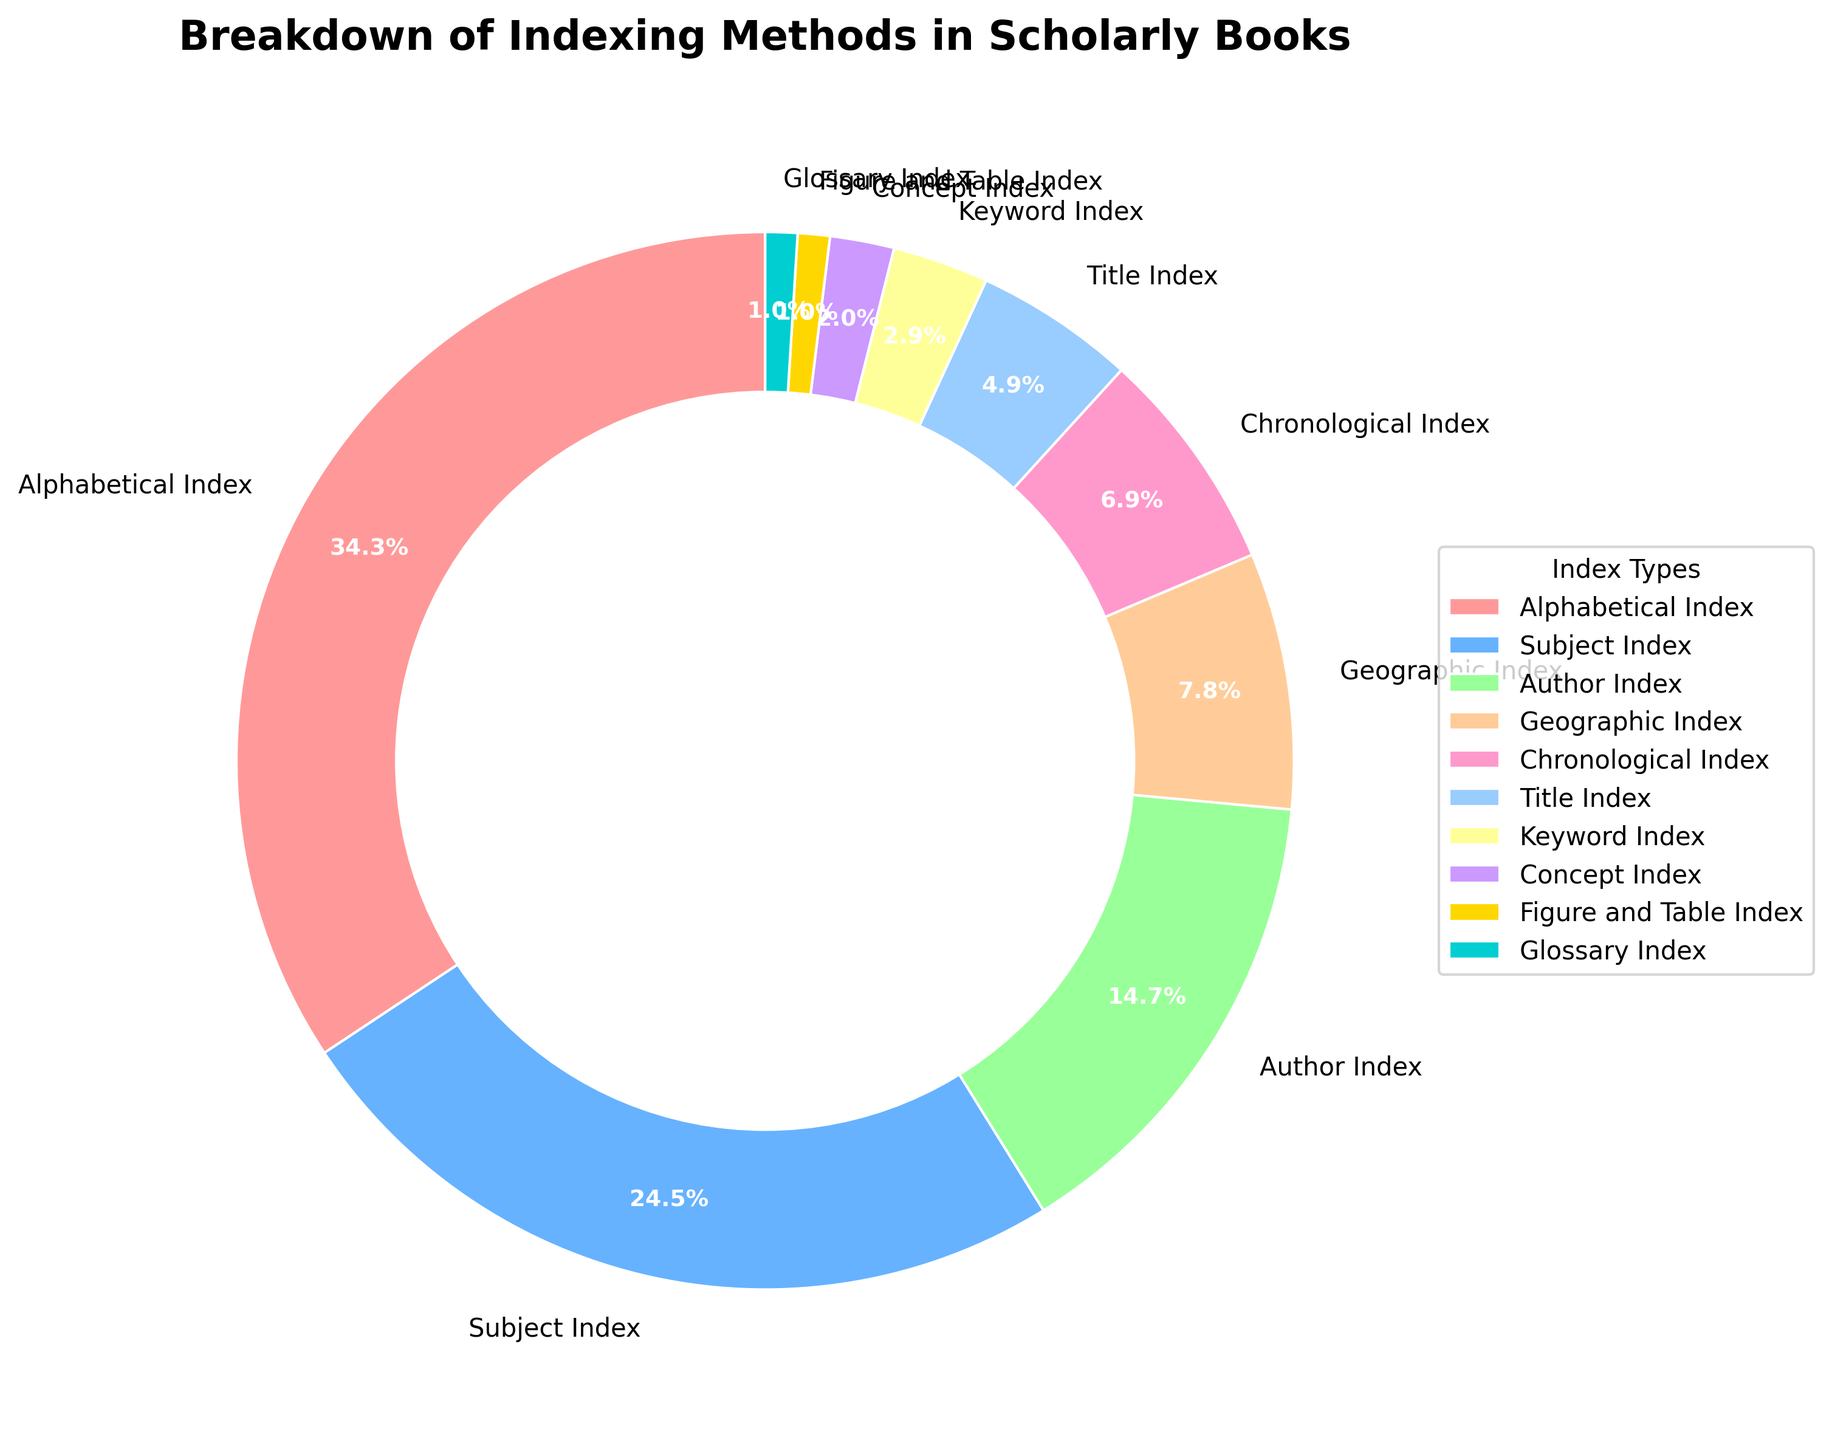Which indexing method is the most commonly used in scholarly books? The pie chart clearly indicates that the "Alphabetical Index" makes up the largest portion, represented by the largest wedge in the chart, at 35%.
Answer: Alphabetical Index What percentage of scholarly books use either a Geographic Index or a Chronological Index? The chart indicates that the Geographic Index is 8% and the Chronological Index is 7%. Adding these two percentages together results in 8% + 7% = 15%.
Answer: 15% Which indexing method has the smallest use in scholarly books? The smallest wedges in the pie chart representing 1% each are the "Figure and Table Index" and the "Glossary Index". They are equally the least used methods.
Answer: Figure and Table Index, Glossary Index How does the usage of the Subject Index compare to the Author Index? According to the pie chart, the Subject Index is used 25% of the time, whereas the Author Index is used 15% of the time. Thus, the Subject Index is used more frequently.
Answer: Subject Index is used more What is the combined percentage of scholarly books that use Keyword Index and Concept Index? The pie chart shows that Keyword Index is 3% and Concept Index is 2%. Combining these two percentages results in 3% + 2% = 5%.
Answer: 5% Is the usage of the Title Index closer to the usage of the Geographic Index or the Chronological Index? The pie chart shows that the Title Index is 5%, the Geographic Index is 8%, and the Chronological Index is 7%. Since 5% is closer to 7% than 8%, the Title Index is closer in usage to the Chronological Index.
Answer: Chronological Index What is the difference in percentage between the Author Index and the Glossary Index? The pie chart shows that the Author Index is 15% and the Glossary Index is 1%. The difference is 15% - 1% = 14%.
Answer: 14% How much larger is the usage of the Alphabetical Index compared to the Title Index? The pie chart shows that the Alphabetical Index is 35% and the Title Index is 5%. The difference is 35% - 5% = 30%.
Answer: 30% 